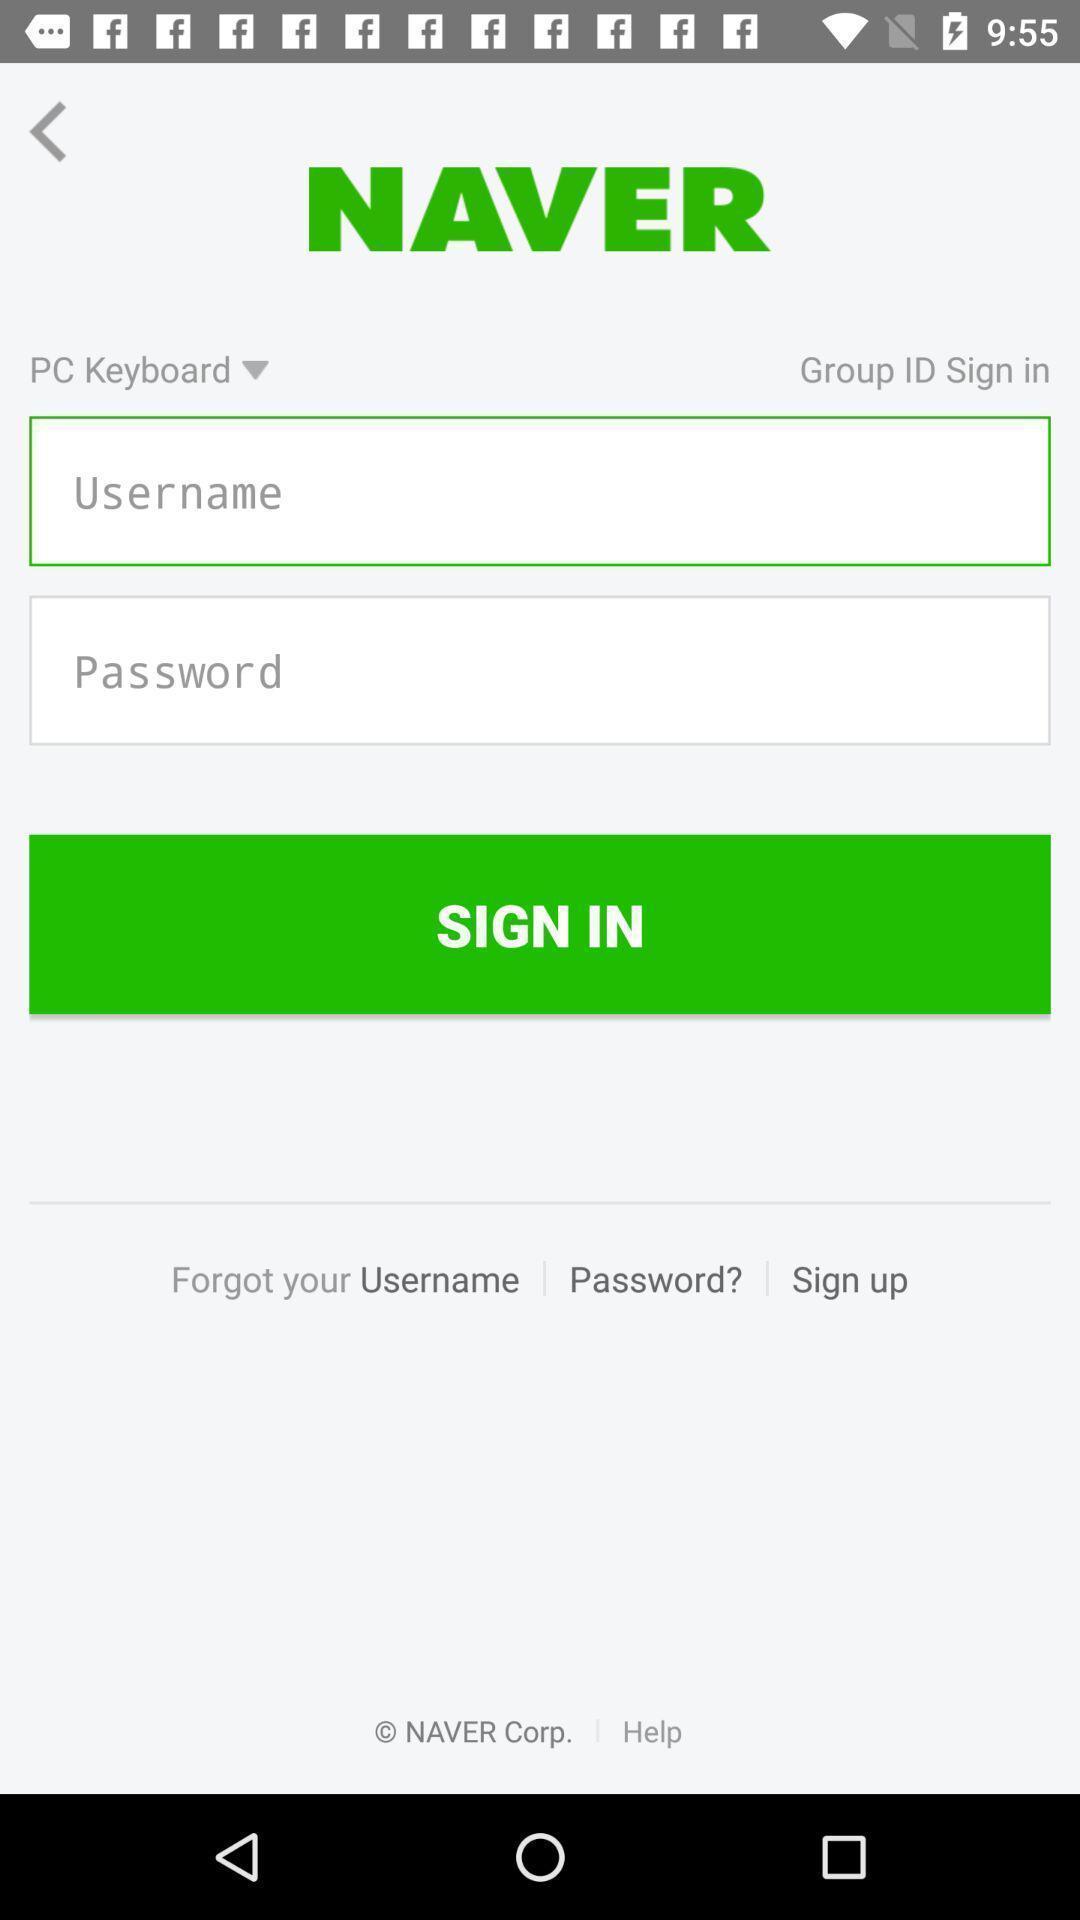Describe this image in words. Sign-in page of a mailing app. 